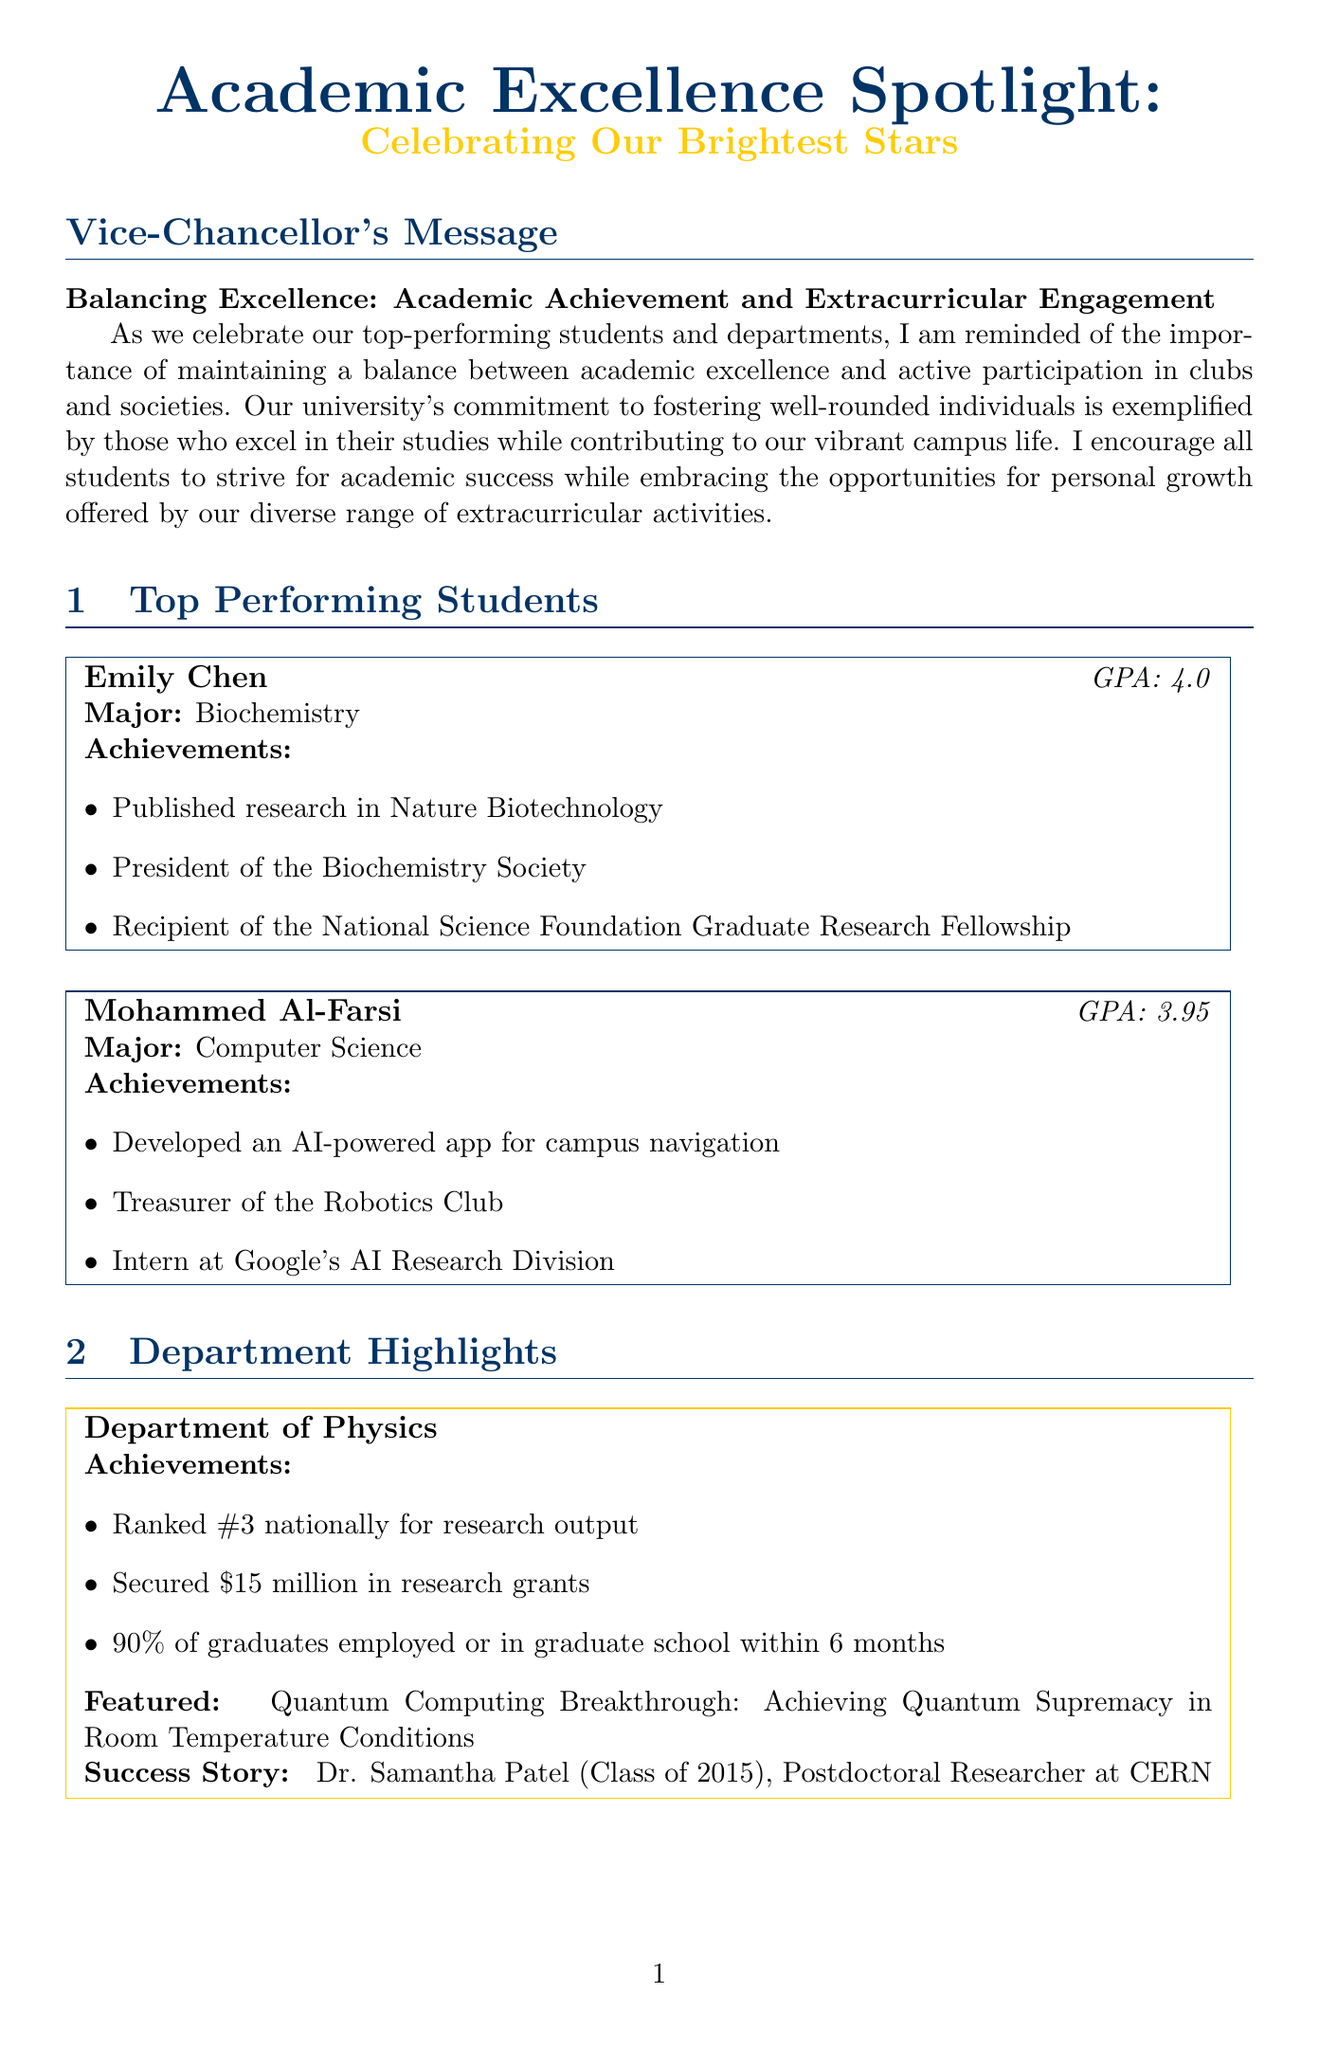What is the title of the newsletter? The title of the newsletter is stated prominently at the beginning, introducing the theme of academic excellence.
Answer: Academic Excellence Spotlight: Celebrating Our Brightest Stars Who is the president of the Biochemistry Society? The newsletter highlights Emily Chen's achievements, including her role as the president of the Biochemistry Society.
Answer: Emily Chen What is the GPA of Mohammed Al-Farsi? Mohammed Al-Farsi's academic performance is specified as part of his introduction as a top-performing student.
Answer: 3.95 Which department is ranked #3 nationally for research output? The achievements of the Department of Physics indicate its notable national ranking for research output.
Answer: Department of Physics How many Rhodes Scholars has the university had in the past 5 years? This statistic is explicitly listed in the infographic section detailing academic excellence by the numbers.
Answer: 3 What was the average GPA reported in the newsletter? The infographic provides a clear figure regarding the average GPA of the students at the university.
Answer: 3.6 What initiative funded 10 student startups in the past year? The School of Business highlights a specific program that has supported student entrepreneurship.
Answer: Entrepreneurship Incubator Program Who is the CFO of Stripe? The newsletter mentions Marcus Johnson's current position as part of the alumni spotlight in the School of Business section.
Answer: Marcus Johnson What percentage of juniors and seniors have internship placements according to the School of Business? This data is included in the achievements of the School of Business, indicating its effectiveness in providing internships.
Answer: 95% 